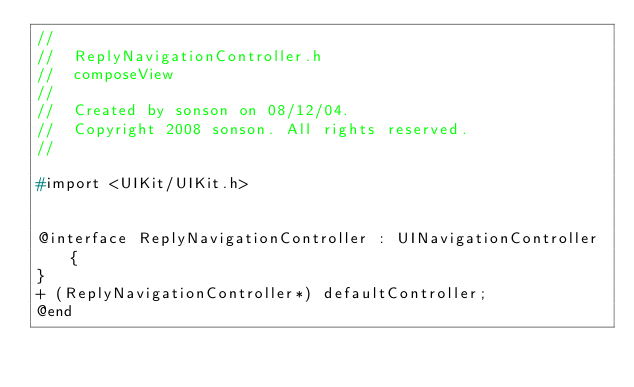<code> <loc_0><loc_0><loc_500><loc_500><_C_>//
//  ReplyNavigationController.h
//  composeView
//
//  Created by sonson on 08/12/04.
//  Copyright 2008 sonson. All rights reserved.
//

#import <UIKit/UIKit.h>


@interface ReplyNavigationController : UINavigationController {
}
+ (ReplyNavigationController*) defaultController;
@end
</code> 